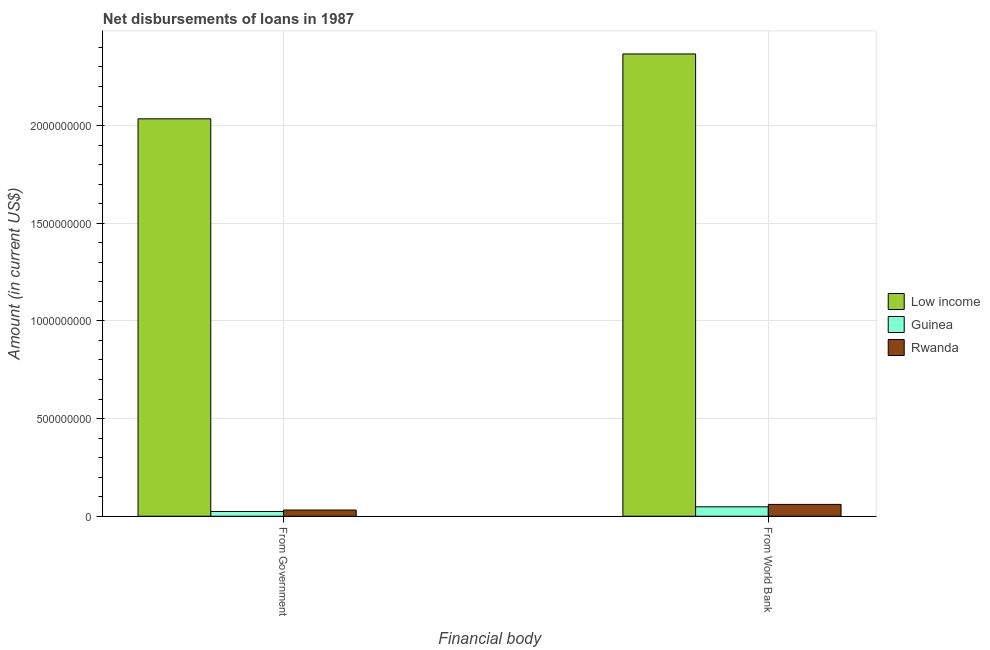How many different coloured bars are there?
Your answer should be very brief. 3. How many groups of bars are there?
Your answer should be very brief. 2. Are the number of bars per tick equal to the number of legend labels?
Provide a succinct answer. Yes. How many bars are there on the 1st tick from the right?
Provide a succinct answer. 3. What is the label of the 1st group of bars from the left?
Provide a succinct answer. From Government. What is the net disbursements of loan from government in Rwanda?
Your answer should be compact. 3.18e+07. Across all countries, what is the maximum net disbursements of loan from world bank?
Ensure brevity in your answer.  2.37e+09. Across all countries, what is the minimum net disbursements of loan from government?
Offer a very short reply. 2.44e+07. In which country was the net disbursements of loan from government minimum?
Keep it short and to the point. Guinea. What is the total net disbursements of loan from government in the graph?
Your response must be concise. 2.09e+09. What is the difference between the net disbursements of loan from world bank in Rwanda and that in Guinea?
Provide a succinct answer. 1.23e+07. What is the difference between the net disbursements of loan from government in Rwanda and the net disbursements of loan from world bank in Low income?
Provide a succinct answer. -2.33e+09. What is the average net disbursements of loan from government per country?
Ensure brevity in your answer.  6.97e+08. What is the difference between the net disbursements of loan from government and net disbursements of loan from world bank in Rwanda?
Offer a terse response. -2.88e+07. In how many countries, is the net disbursements of loan from world bank greater than 2300000000 US$?
Provide a succinct answer. 1. What is the ratio of the net disbursements of loan from government in Rwanda to that in Guinea?
Ensure brevity in your answer.  1.3. Is the net disbursements of loan from government in Guinea less than that in Rwanda?
Your response must be concise. Yes. In how many countries, is the net disbursements of loan from world bank greater than the average net disbursements of loan from world bank taken over all countries?
Your response must be concise. 1. What does the 3rd bar from the left in From Government represents?
Ensure brevity in your answer.  Rwanda. What does the 2nd bar from the right in From World Bank represents?
Provide a short and direct response. Guinea. What is the difference between two consecutive major ticks on the Y-axis?
Your response must be concise. 5.00e+08. Does the graph contain any zero values?
Give a very brief answer. No. How are the legend labels stacked?
Offer a very short reply. Vertical. What is the title of the graph?
Your answer should be very brief. Net disbursements of loans in 1987. What is the label or title of the X-axis?
Your response must be concise. Financial body. What is the Amount (in current US$) in Low income in From Government?
Offer a very short reply. 2.03e+09. What is the Amount (in current US$) in Guinea in From Government?
Offer a terse response. 2.44e+07. What is the Amount (in current US$) of Rwanda in From Government?
Ensure brevity in your answer.  3.18e+07. What is the Amount (in current US$) in Low income in From World Bank?
Your answer should be compact. 2.37e+09. What is the Amount (in current US$) of Guinea in From World Bank?
Your answer should be compact. 4.83e+07. What is the Amount (in current US$) of Rwanda in From World Bank?
Give a very brief answer. 6.06e+07. Across all Financial body, what is the maximum Amount (in current US$) in Low income?
Your answer should be compact. 2.37e+09. Across all Financial body, what is the maximum Amount (in current US$) in Guinea?
Provide a succinct answer. 4.83e+07. Across all Financial body, what is the maximum Amount (in current US$) of Rwanda?
Give a very brief answer. 6.06e+07. Across all Financial body, what is the minimum Amount (in current US$) of Low income?
Provide a succinct answer. 2.03e+09. Across all Financial body, what is the minimum Amount (in current US$) in Guinea?
Offer a very short reply. 2.44e+07. Across all Financial body, what is the minimum Amount (in current US$) in Rwanda?
Keep it short and to the point. 3.18e+07. What is the total Amount (in current US$) in Low income in the graph?
Ensure brevity in your answer.  4.40e+09. What is the total Amount (in current US$) in Guinea in the graph?
Provide a succinct answer. 7.27e+07. What is the total Amount (in current US$) in Rwanda in the graph?
Keep it short and to the point. 9.24e+07. What is the difference between the Amount (in current US$) in Low income in From Government and that in From World Bank?
Your response must be concise. -3.32e+08. What is the difference between the Amount (in current US$) of Guinea in From Government and that in From World Bank?
Your answer should be very brief. -2.38e+07. What is the difference between the Amount (in current US$) of Rwanda in From Government and that in From World Bank?
Your answer should be compact. -2.88e+07. What is the difference between the Amount (in current US$) of Low income in From Government and the Amount (in current US$) of Guinea in From World Bank?
Provide a succinct answer. 1.99e+09. What is the difference between the Amount (in current US$) of Low income in From Government and the Amount (in current US$) of Rwanda in From World Bank?
Provide a succinct answer. 1.97e+09. What is the difference between the Amount (in current US$) of Guinea in From Government and the Amount (in current US$) of Rwanda in From World Bank?
Offer a very short reply. -3.62e+07. What is the average Amount (in current US$) in Low income per Financial body?
Offer a very short reply. 2.20e+09. What is the average Amount (in current US$) of Guinea per Financial body?
Ensure brevity in your answer.  3.64e+07. What is the average Amount (in current US$) in Rwanda per Financial body?
Your response must be concise. 4.62e+07. What is the difference between the Amount (in current US$) of Low income and Amount (in current US$) of Guinea in From Government?
Your answer should be compact. 2.01e+09. What is the difference between the Amount (in current US$) in Low income and Amount (in current US$) in Rwanda in From Government?
Your answer should be compact. 2.00e+09. What is the difference between the Amount (in current US$) of Guinea and Amount (in current US$) of Rwanda in From Government?
Provide a short and direct response. -7.36e+06. What is the difference between the Amount (in current US$) in Low income and Amount (in current US$) in Guinea in From World Bank?
Offer a terse response. 2.32e+09. What is the difference between the Amount (in current US$) in Low income and Amount (in current US$) in Rwanda in From World Bank?
Keep it short and to the point. 2.31e+09. What is the difference between the Amount (in current US$) of Guinea and Amount (in current US$) of Rwanda in From World Bank?
Keep it short and to the point. -1.23e+07. What is the ratio of the Amount (in current US$) in Low income in From Government to that in From World Bank?
Your answer should be compact. 0.86. What is the ratio of the Amount (in current US$) of Guinea in From Government to that in From World Bank?
Your answer should be very brief. 0.51. What is the ratio of the Amount (in current US$) of Rwanda in From Government to that in From World Bank?
Ensure brevity in your answer.  0.52. What is the difference between the highest and the second highest Amount (in current US$) of Low income?
Your response must be concise. 3.32e+08. What is the difference between the highest and the second highest Amount (in current US$) in Guinea?
Give a very brief answer. 2.38e+07. What is the difference between the highest and the second highest Amount (in current US$) in Rwanda?
Ensure brevity in your answer.  2.88e+07. What is the difference between the highest and the lowest Amount (in current US$) of Low income?
Ensure brevity in your answer.  3.32e+08. What is the difference between the highest and the lowest Amount (in current US$) in Guinea?
Provide a succinct answer. 2.38e+07. What is the difference between the highest and the lowest Amount (in current US$) of Rwanda?
Provide a short and direct response. 2.88e+07. 